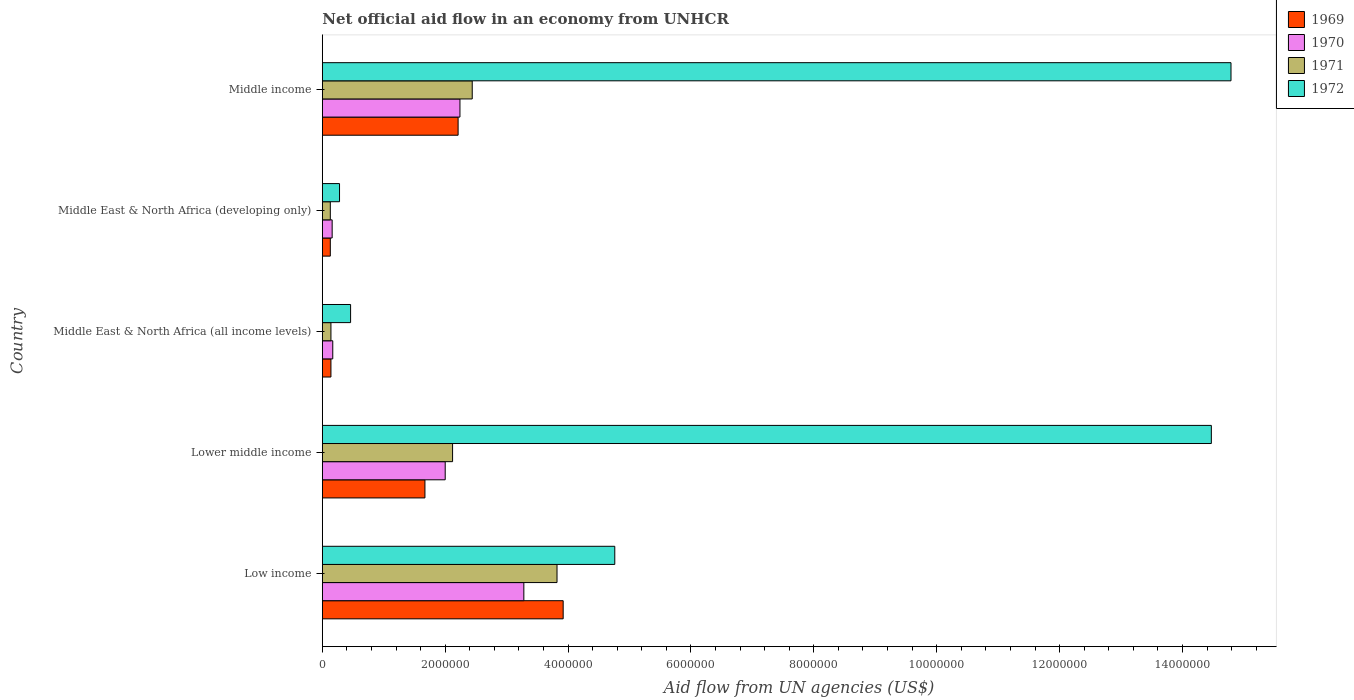How many different coloured bars are there?
Make the answer very short. 4. How many bars are there on the 3rd tick from the top?
Make the answer very short. 4. How many bars are there on the 1st tick from the bottom?
Your answer should be very brief. 4. What is the label of the 3rd group of bars from the top?
Provide a short and direct response. Middle East & North Africa (all income levels). What is the net official aid flow in 1969 in Middle income?
Your response must be concise. 2.21e+06. Across all countries, what is the maximum net official aid flow in 1972?
Provide a succinct answer. 1.48e+07. Across all countries, what is the minimum net official aid flow in 1970?
Offer a terse response. 1.60e+05. In which country was the net official aid flow in 1971 minimum?
Provide a short and direct response. Middle East & North Africa (developing only). What is the total net official aid flow in 1970 in the graph?
Your answer should be compact. 7.85e+06. What is the difference between the net official aid flow in 1971 in Middle income and the net official aid flow in 1972 in Low income?
Ensure brevity in your answer.  -2.32e+06. What is the average net official aid flow in 1971 per country?
Provide a short and direct response. 1.73e+06. What is the difference between the net official aid flow in 1972 and net official aid flow in 1970 in Middle income?
Give a very brief answer. 1.26e+07. What is the difference between the highest and the second highest net official aid flow in 1970?
Your response must be concise. 1.04e+06. What is the difference between the highest and the lowest net official aid flow in 1969?
Your response must be concise. 3.79e+06. Is it the case that in every country, the sum of the net official aid flow in 1971 and net official aid flow in 1969 is greater than the sum of net official aid flow in 1972 and net official aid flow in 1970?
Provide a succinct answer. No. What does the 4th bar from the top in Lower middle income represents?
Keep it short and to the point. 1969. What does the 1st bar from the bottom in Low income represents?
Offer a very short reply. 1969. How many countries are there in the graph?
Your answer should be compact. 5. How many legend labels are there?
Give a very brief answer. 4. How are the legend labels stacked?
Make the answer very short. Vertical. What is the title of the graph?
Ensure brevity in your answer.  Net official aid flow in an economy from UNHCR. What is the label or title of the X-axis?
Keep it short and to the point. Aid flow from UN agencies (US$). What is the label or title of the Y-axis?
Your answer should be compact. Country. What is the Aid flow from UN agencies (US$) in 1969 in Low income?
Keep it short and to the point. 3.92e+06. What is the Aid flow from UN agencies (US$) in 1970 in Low income?
Your answer should be compact. 3.28e+06. What is the Aid flow from UN agencies (US$) in 1971 in Low income?
Your answer should be compact. 3.82e+06. What is the Aid flow from UN agencies (US$) in 1972 in Low income?
Ensure brevity in your answer.  4.76e+06. What is the Aid flow from UN agencies (US$) of 1969 in Lower middle income?
Your response must be concise. 1.67e+06. What is the Aid flow from UN agencies (US$) in 1970 in Lower middle income?
Your answer should be very brief. 2.00e+06. What is the Aid flow from UN agencies (US$) of 1971 in Lower middle income?
Keep it short and to the point. 2.12e+06. What is the Aid flow from UN agencies (US$) of 1972 in Lower middle income?
Ensure brevity in your answer.  1.45e+07. What is the Aid flow from UN agencies (US$) in 1969 in Middle East & North Africa (all income levels)?
Provide a short and direct response. 1.40e+05. What is the Aid flow from UN agencies (US$) of 1970 in Middle East & North Africa (all income levels)?
Provide a short and direct response. 1.70e+05. What is the Aid flow from UN agencies (US$) of 1971 in Middle East & North Africa (all income levels)?
Your response must be concise. 1.40e+05. What is the Aid flow from UN agencies (US$) in 1972 in Middle East & North Africa (all income levels)?
Keep it short and to the point. 4.60e+05. What is the Aid flow from UN agencies (US$) in 1970 in Middle East & North Africa (developing only)?
Your response must be concise. 1.60e+05. What is the Aid flow from UN agencies (US$) in 1972 in Middle East & North Africa (developing only)?
Offer a terse response. 2.80e+05. What is the Aid flow from UN agencies (US$) in 1969 in Middle income?
Offer a very short reply. 2.21e+06. What is the Aid flow from UN agencies (US$) of 1970 in Middle income?
Give a very brief answer. 2.24e+06. What is the Aid flow from UN agencies (US$) of 1971 in Middle income?
Ensure brevity in your answer.  2.44e+06. What is the Aid flow from UN agencies (US$) of 1972 in Middle income?
Provide a succinct answer. 1.48e+07. Across all countries, what is the maximum Aid flow from UN agencies (US$) in 1969?
Make the answer very short. 3.92e+06. Across all countries, what is the maximum Aid flow from UN agencies (US$) of 1970?
Keep it short and to the point. 3.28e+06. Across all countries, what is the maximum Aid flow from UN agencies (US$) in 1971?
Keep it short and to the point. 3.82e+06. Across all countries, what is the maximum Aid flow from UN agencies (US$) in 1972?
Offer a very short reply. 1.48e+07. Across all countries, what is the minimum Aid flow from UN agencies (US$) of 1969?
Your response must be concise. 1.30e+05. Across all countries, what is the minimum Aid flow from UN agencies (US$) of 1971?
Provide a short and direct response. 1.30e+05. Across all countries, what is the minimum Aid flow from UN agencies (US$) in 1972?
Offer a very short reply. 2.80e+05. What is the total Aid flow from UN agencies (US$) of 1969 in the graph?
Make the answer very short. 8.07e+06. What is the total Aid flow from UN agencies (US$) in 1970 in the graph?
Offer a terse response. 7.85e+06. What is the total Aid flow from UN agencies (US$) of 1971 in the graph?
Ensure brevity in your answer.  8.65e+06. What is the total Aid flow from UN agencies (US$) of 1972 in the graph?
Your answer should be compact. 3.48e+07. What is the difference between the Aid flow from UN agencies (US$) of 1969 in Low income and that in Lower middle income?
Give a very brief answer. 2.25e+06. What is the difference between the Aid flow from UN agencies (US$) in 1970 in Low income and that in Lower middle income?
Keep it short and to the point. 1.28e+06. What is the difference between the Aid flow from UN agencies (US$) of 1971 in Low income and that in Lower middle income?
Ensure brevity in your answer.  1.70e+06. What is the difference between the Aid flow from UN agencies (US$) of 1972 in Low income and that in Lower middle income?
Provide a short and direct response. -9.71e+06. What is the difference between the Aid flow from UN agencies (US$) of 1969 in Low income and that in Middle East & North Africa (all income levels)?
Your response must be concise. 3.78e+06. What is the difference between the Aid flow from UN agencies (US$) of 1970 in Low income and that in Middle East & North Africa (all income levels)?
Your answer should be compact. 3.11e+06. What is the difference between the Aid flow from UN agencies (US$) of 1971 in Low income and that in Middle East & North Africa (all income levels)?
Provide a succinct answer. 3.68e+06. What is the difference between the Aid flow from UN agencies (US$) of 1972 in Low income and that in Middle East & North Africa (all income levels)?
Your answer should be very brief. 4.30e+06. What is the difference between the Aid flow from UN agencies (US$) of 1969 in Low income and that in Middle East & North Africa (developing only)?
Ensure brevity in your answer.  3.79e+06. What is the difference between the Aid flow from UN agencies (US$) in 1970 in Low income and that in Middle East & North Africa (developing only)?
Offer a terse response. 3.12e+06. What is the difference between the Aid flow from UN agencies (US$) in 1971 in Low income and that in Middle East & North Africa (developing only)?
Your response must be concise. 3.69e+06. What is the difference between the Aid flow from UN agencies (US$) in 1972 in Low income and that in Middle East & North Africa (developing only)?
Keep it short and to the point. 4.48e+06. What is the difference between the Aid flow from UN agencies (US$) in 1969 in Low income and that in Middle income?
Provide a short and direct response. 1.71e+06. What is the difference between the Aid flow from UN agencies (US$) of 1970 in Low income and that in Middle income?
Your answer should be compact. 1.04e+06. What is the difference between the Aid flow from UN agencies (US$) of 1971 in Low income and that in Middle income?
Ensure brevity in your answer.  1.38e+06. What is the difference between the Aid flow from UN agencies (US$) in 1972 in Low income and that in Middle income?
Your answer should be very brief. -1.00e+07. What is the difference between the Aid flow from UN agencies (US$) in 1969 in Lower middle income and that in Middle East & North Africa (all income levels)?
Provide a succinct answer. 1.53e+06. What is the difference between the Aid flow from UN agencies (US$) of 1970 in Lower middle income and that in Middle East & North Africa (all income levels)?
Your answer should be very brief. 1.83e+06. What is the difference between the Aid flow from UN agencies (US$) in 1971 in Lower middle income and that in Middle East & North Africa (all income levels)?
Offer a terse response. 1.98e+06. What is the difference between the Aid flow from UN agencies (US$) in 1972 in Lower middle income and that in Middle East & North Africa (all income levels)?
Your answer should be compact. 1.40e+07. What is the difference between the Aid flow from UN agencies (US$) in 1969 in Lower middle income and that in Middle East & North Africa (developing only)?
Offer a very short reply. 1.54e+06. What is the difference between the Aid flow from UN agencies (US$) in 1970 in Lower middle income and that in Middle East & North Africa (developing only)?
Make the answer very short. 1.84e+06. What is the difference between the Aid flow from UN agencies (US$) of 1971 in Lower middle income and that in Middle East & North Africa (developing only)?
Keep it short and to the point. 1.99e+06. What is the difference between the Aid flow from UN agencies (US$) in 1972 in Lower middle income and that in Middle East & North Africa (developing only)?
Offer a very short reply. 1.42e+07. What is the difference between the Aid flow from UN agencies (US$) in 1969 in Lower middle income and that in Middle income?
Offer a terse response. -5.40e+05. What is the difference between the Aid flow from UN agencies (US$) of 1970 in Lower middle income and that in Middle income?
Offer a very short reply. -2.40e+05. What is the difference between the Aid flow from UN agencies (US$) in 1971 in Lower middle income and that in Middle income?
Give a very brief answer. -3.20e+05. What is the difference between the Aid flow from UN agencies (US$) in 1972 in Lower middle income and that in Middle income?
Offer a terse response. -3.20e+05. What is the difference between the Aid flow from UN agencies (US$) in 1972 in Middle East & North Africa (all income levels) and that in Middle East & North Africa (developing only)?
Your response must be concise. 1.80e+05. What is the difference between the Aid flow from UN agencies (US$) of 1969 in Middle East & North Africa (all income levels) and that in Middle income?
Offer a terse response. -2.07e+06. What is the difference between the Aid flow from UN agencies (US$) of 1970 in Middle East & North Africa (all income levels) and that in Middle income?
Provide a succinct answer. -2.07e+06. What is the difference between the Aid flow from UN agencies (US$) of 1971 in Middle East & North Africa (all income levels) and that in Middle income?
Provide a short and direct response. -2.30e+06. What is the difference between the Aid flow from UN agencies (US$) in 1972 in Middle East & North Africa (all income levels) and that in Middle income?
Provide a short and direct response. -1.43e+07. What is the difference between the Aid flow from UN agencies (US$) in 1969 in Middle East & North Africa (developing only) and that in Middle income?
Ensure brevity in your answer.  -2.08e+06. What is the difference between the Aid flow from UN agencies (US$) of 1970 in Middle East & North Africa (developing only) and that in Middle income?
Your response must be concise. -2.08e+06. What is the difference between the Aid flow from UN agencies (US$) of 1971 in Middle East & North Africa (developing only) and that in Middle income?
Offer a terse response. -2.31e+06. What is the difference between the Aid flow from UN agencies (US$) of 1972 in Middle East & North Africa (developing only) and that in Middle income?
Your response must be concise. -1.45e+07. What is the difference between the Aid flow from UN agencies (US$) of 1969 in Low income and the Aid flow from UN agencies (US$) of 1970 in Lower middle income?
Your answer should be very brief. 1.92e+06. What is the difference between the Aid flow from UN agencies (US$) in 1969 in Low income and the Aid flow from UN agencies (US$) in 1971 in Lower middle income?
Offer a terse response. 1.80e+06. What is the difference between the Aid flow from UN agencies (US$) of 1969 in Low income and the Aid flow from UN agencies (US$) of 1972 in Lower middle income?
Your answer should be compact. -1.06e+07. What is the difference between the Aid flow from UN agencies (US$) of 1970 in Low income and the Aid flow from UN agencies (US$) of 1971 in Lower middle income?
Ensure brevity in your answer.  1.16e+06. What is the difference between the Aid flow from UN agencies (US$) of 1970 in Low income and the Aid flow from UN agencies (US$) of 1972 in Lower middle income?
Your response must be concise. -1.12e+07. What is the difference between the Aid flow from UN agencies (US$) of 1971 in Low income and the Aid flow from UN agencies (US$) of 1972 in Lower middle income?
Make the answer very short. -1.06e+07. What is the difference between the Aid flow from UN agencies (US$) of 1969 in Low income and the Aid flow from UN agencies (US$) of 1970 in Middle East & North Africa (all income levels)?
Offer a terse response. 3.75e+06. What is the difference between the Aid flow from UN agencies (US$) in 1969 in Low income and the Aid flow from UN agencies (US$) in 1971 in Middle East & North Africa (all income levels)?
Keep it short and to the point. 3.78e+06. What is the difference between the Aid flow from UN agencies (US$) of 1969 in Low income and the Aid flow from UN agencies (US$) of 1972 in Middle East & North Africa (all income levels)?
Provide a short and direct response. 3.46e+06. What is the difference between the Aid flow from UN agencies (US$) in 1970 in Low income and the Aid flow from UN agencies (US$) in 1971 in Middle East & North Africa (all income levels)?
Make the answer very short. 3.14e+06. What is the difference between the Aid flow from UN agencies (US$) in 1970 in Low income and the Aid flow from UN agencies (US$) in 1972 in Middle East & North Africa (all income levels)?
Offer a terse response. 2.82e+06. What is the difference between the Aid flow from UN agencies (US$) of 1971 in Low income and the Aid flow from UN agencies (US$) of 1972 in Middle East & North Africa (all income levels)?
Your answer should be very brief. 3.36e+06. What is the difference between the Aid flow from UN agencies (US$) of 1969 in Low income and the Aid flow from UN agencies (US$) of 1970 in Middle East & North Africa (developing only)?
Make the answer very short. 3.76e+06. What is the difference between the Aid flow from UN agencies (US$) in 1969 in Low income and the Aid flow from UN agencies (US$) in 1971 in Middle East & North Africa (developing only)?
Offer a terse response. 3.79e+06. What is the difference between the Aid flow from UN agencies (US$) in 1969 in Low income and the Aid flow from UN agencies (US$) in 1972 in Middle East & North Africa (developing only)?
Give a very brief answer. 3.64e+06. What is the difference between the Aid flow from UN agencies (US$) in 1970 in Low income and the Aid flow from UN agencies (US$) in 1971 in Middle East & North Africa (developing only)?
Your answer should be very brief. 3.15e+06. What is the difference between the Aid flow from UN agencies (US$) in 1970 in Low income and the Aid flow from UN agencies (US$) in 1972 in Middle East & North Africa (developing only)?
Ensure brevity in your answer.  3.00e+06. What is the difference between the Aid flow from UN agencies (US$) of 1971 in Low income and the Aid flow from UN agencies (US$) of 1972 in Middle East & North Africa (developing only)?
Make the answer very short. 3.54e+06. What is the difference between the Aid flow from UN agencies (US$) of 1969 in Low income and the Aid flow from UN agencies (US$) of 1970 in Middle income?
Provide a short and direct response. 1.68e+06. What is the difference between the Aid flow from UN agencies (US$) in 1969 in Low income and the Aid flow from UN agencies (US$) in 1971 in Middle income?
Make the answer very short. 1.48e+06. What is the difference between the Aid flow from UN agencies (US$) of 1969 in Low income and the Aid flow from UN agencies (US$) of 1972 in Middle income?
Give a very brief answer. -1.09e+07. What is the difference between the Aid flow from UN agencies (US$) in 1970 in Low income and the Aid flow from UN agencies (US$) in 1971 in Middle income?
Your answer should be very brief. 8.40e+05. What is the difference between the Aid flow from UN agencies (US$) in 1970 in Low income and the Aid flow from UN agencies (US$) in 1972 in Middle income?
Your response must be concise. -1.15e+07. What is the difference between the Aid flow from UN agencies (US$) in 1971 in Low income and the Aid flow from UN agencies (US$) in 1972 in Middle income?
Your answer should be compact. -1.10e+07. What is the difference between the Aid flow from UN agencies (US$) of 1969 in Lower middle income and the Aid flow from UN agencies (US$) of 1970 in Middle East & North Africa (all income levels)?
Your answer should be compact. 1.50e+06. What is the difference between the Aid flow from UN agencies (US$) in 1969 in Lower middle income and the Aid flow from UN agencies (US$) in 1971 in Middle East & North Africa (all income levels)?
Your response must be concise. 1.53e+06. What is the difference between the Aid flow from UN agencies (US$) of 1969 in Lower middle income and the Aid flow from UN agencies (US$) of 1972 in Middle East & North Africa (all income levels)?
Provide a succinct answer. 1.21e+06. What is the difference between the Aid flow from UN agencies (US$) in 1970 in Lower middle income and the Aid flow from UN agencies (US$) in 1971 in Middle East & North Africa (all income levels)?
Provide a succinct answer. 1.86e+06. What is the difference between the Aid flow from UN agencies (US$) of 1970 in Lower middle income and the Aid flow from UN agencies (US$) of 1972 in Middle East & North Africa (all income levels)?
Provide a succinct answer. 1.54e+06. What is the difference between the Aid flow from UN agencies (US$) in 1971 in Lower middle income and the Aid flow from UN agencies (US$) in 1972 in Middle East & North Africa (all income levels)?
Offer a very short reply. 1.66e+06. What is the difference between the Aid flow from UN agencies (US$) in 1969 in Lower middle income and the Aid flow from UN agencies (US$) in 1970 in Middle East & North Africa (developing only)?
Ensure brevity in your answer.  1.51e+06. What is the difference between the Aid flow from UN agencies (US$) of 1969 in Lower middle income and the Aid flow from UN agencies (US$) of 1971 in Middle East & North Africa (developing only)?
Your answer should be compact. 1.54e+06. What is the difference between the Aid flow from UN agencies (US$) in 1969 in Lower middle income and the Aid flow from UN agencies (US$) in 1972 in Middle East & North Africa (developing only)?
Offer a terse response. 1.39e+06. What is the difference between the Aid flow from UN agencies (US$) of 1970 in Lower middle income and the Aid flow from UN agencies (US$) of 1971 in Middle East & North Africa (developing only)?
Your response must be concise. 1.87e+06. What is the difference between the Aid flow from UN agencies (US$) in 1970 in Lower middle income and the Aid flow from UN agencies (US$) in 1972 in Middle East & North Africa (developing only)?
Offer a terse response. 1.72e+06. What is the difference between the Aid flow from UN agencies (US$) of 1971 in Lower middle income and the Aid flow from UN agencies (US$) of 1972 in Middle East & North Africa (developing only)?
Make the answer very short. 1.84e+06. What is the difference between the Aid flow from UN agencies (US$) of 1969 in Lower middle income and the Aid flow from UN agencies (US$) of 1970 in Middle income?
Your answer should be compact. -5.70e+05. What is the difference between the Aid flow from UN agencies (US$) in 1969 in Lower middle income and the Aid flow from UN agencies (US$) in 1971 in Middle income?
Ensure brevity in your answer.  -7.70e+05. What is the difference between the Aid flow from UN agencies (US$) of 1969 in Lower middle income and the Aid flow from UN agencies (US$) of 1972 in Middle income?
Offer a very short reply. -1.31e+07. What is the difference between the Aid flow from UN agencies (US$) in 1970 in Lower middle income and the Aid flow from UN agencies (US$) in 1971 in Middle income?
Make the answer very short. -4.40e+05. What is the difference between the Aid flow from UN agencies (US$) in 1970 in Lower middle income and the Aid flow from UN agencies (US$) in 1972 in Middle income?
Offer a very short reply. -1.28e+07. What is the difference between the Aid flow from UN agencies (US$) in 1971 in Lower middle income and the Aid flow from UN agencies (US$) in 1972 in Middle income?
Your answer should be very brief. -1.27e+07. What is the difference between the Aid flow from UN agencies (US$) in 1969 in Middle East & North Africa (all income levels) and the Aid flow from UN agencies (US$) in 1972 in Middle East & North Africa (developing only)?
Make the answer very short. -1.40e+05. What is the difference between the Aid flow from UN agencies (US$) of 1969 in Middle East & North Africa (all income levels) and the Aid flow from UN agencies (US$) of 1970 in Middle income?
Your response must be concise. -2.10e+06. What is the difference between the Aid flow from UN agencies (US$) of 1969 in Middle East & North Africa (all income levels) and the Aid flow from UN agencies (US$) of 1971 in Middle income?
Ensure brevity in your answer.  -2.30e+06. What is the difference between the Aid flow from UN agencies (US$) in 1969 in Middle East & North Africa (all income levels) and the Aid flow from UN agencies (US$) in 1972 in Middle income?
Provide a succinct answer. -1.46e+07. What is the difference between the Aid flow from UN agencies (US$) of 1970 in Middle East & North Africa (all income levels) and the Aid flow from UN agencies (US$) of 1971 in Middle income?
Offer a terse response. -2.27e+06. What is the difference between the Aid flow from UN agencies (US$) in 1970 in Middle East & North Africa (all income levels) and the Aid flow from UN agencies (US$) in 1972 in Middle income?
Your answer should be very brief. -1.46e+07. What is the difference between the Aid flow from UN agencies (US$) of 1971 in Middle East & North Africa (all income levels) and the Aid flow from UN agencies (US$) of 1972 in Middle income?
Keep it short and to the point. -1.46e+07. What is the difference between the Aid flow from UN agencies (US$) of 1969 in Middle East & North Africa (developing only) and the Aid flow from UN agencies (US$) of 1970 in Middle income?
Give a very brief answer. -2.11e+06. What is the difference between the Aid flow from UN agencies (US$) of 1969 in Middle East & North Africa (developing only) and the Aid flow from UN agencies (US$) of 1971 in Middle income?
Provide a succinct answer. -2.31e+06. What is the difference between the Aid flow from UN agencies (US$) in 1969 in Middle East & North Africa (developing only) and the Aid flow from UN agencies (US$) in 1972 in Middle income?
Your answer should be very brief. -1.47e+07. What is the difference between the Aid flow from UN agencies (US$) in 1970 in Middle East & North Africa (developing only) and the Aid flow from UN agencies (US$) in 1971 in Middle income?
Your answer should be compact. -2.28e+06. What is the difference between the Aid flow from UN agencies (US$) in 1970 in Middle East & North Africa (developing only) and the Aid flow from UN agencies (US$) in 1972 in Middle income?
Offer a terse response. -1.46e+07. What is the difference between the Aid flow from UN agencies (US$) in 1971 in Middle East & North Africa (developing only) and the Aid flow from UN agencies (US$) in 1972 in Middle income?
Give a very brief answer. -1.47e+07. What is the average Aid flow from UN agencies (US$) of 1969 per country?
Provide a succinct answer. 1.61e+06. What is the average Aid flow from UN agencies (US$) in 1970 per country?
Keep it short and to the point. 1.57e+06. What is the average Aid flow from UN agencies (US$) in 1971 per country?
Provide a succinct answer. 1.73e+06. What is the average Aid flow from UN agencies (US$) of 1972 per country?
Keep it short and to the point. 6.95e+06. What is the difference between the Aid flow from UN agencies (US$) of 1969 and Aid flow from UN agencies (US$) of 1970 in Low income?
Your response must be concise. 6.40e+05. What is the difference between the Aid flow from UN agencies (US$) of 1969 and Aid flow from UN agencies (US$) of 1972 in Low income?
Your answer should be very brief. -8.40e+05. What is the difference between the Aid flow from UN agencies (US$) in 1970 and Aid flow from UN agencies (US$) in 1971 in Low income?
Make the answer very short. -5.40e+05. What is the difference between the Aid flow from UN agencies (US$) of 1970 and Aid flow from UN agencies (US$) of 1972 in Low income?
Offer a very short reply. -1.48e+06. What is the difference between the Aid flow from UN agencies (US$) of 1971 and Aid flow from UN agencies (US$) of 1972 in Low income?
Ensure brevity in your answer.  -9.40e+05. What is the difference between the Aid flow from UN agencies (US$) in 1969 and Aid flow from UN agencies (US$) in 1970 in Lower middle income?
Keep it short and to the point. -3.30e+05. What is the difference between the Aid flow from UN agencies (US$) of 1969 and Aid flow from UN agencies (US$) of 1971 in Lower middle income?
Your answer should be very brief. -4.50e+05. What is the difference between the Aid flow from UN agencies (US$) of 1969 and Aid flow from UN agencies (US$) of 1972 in Lower middle income?
Your answer should be very brief. -1.28e+07. What is the difference between the Aid flow from UN agencies (US$) in 1970 and Aid flow from UN agencies (US$) in 1971 in Lower middle income?
Your response must be concise. -1.20e+05. What is the difference between the Aid flow from UN agencies (US$) in 1970 and Aid flow from UN agencies (US$) in 1972 in Lower middle income?
Your response must be concise. -1.25e+07. What is the difference between the Aid flow from UN agencies (US$) of 1971 and Aid flow from UN agencies (US$) of 1972 in Lower middle income?
Give a very brief answer. -1.24e+07. What is the difference between the Aid flow from UN agencies (US$) in 1969 and Aid flow from UN agencies (US$) in 1970 in Middle East & North Africa (all income levels)?
Offer a terse response. -3.00e+04. What is the difference between the Aid flow from UN agencies (US$) in 1969 and Aid flow from UN agencies (US$) in 1971 in Middle East & North Africa (all income levels)?
Give a very brief answer. 0. What is the difference between the Aid flow from UN agencies (US$) in 1969 and Aid flow from UN agencies (US$) in 1972 in Middle East & North Africa (all income levels)?
Keep it short and to the point. -3.20e+05. What is the difference between the Aid flow from UN agencies (US$) in 1970 and Aid flow from UN agencies (US$) in 1971 in Middle East & North Africa (all income levels)?
Your answer should be compact. 3.00e+04. What is the difference between the Aid flow from UN agencies (US$) of 1970 and Aid flow from UN agencies (US$) of 1972 in Middle East & North Africa (all income levels)?
Offer a terse response. -2.90e+05. What is the difference between the Aid flow from UN agencies (US$) in 1971 and Aid flow from UN agencies (US$) in 1972 in Middle East & North Africa (all income levels)?
Give a very brief answer. -3.20e+05. What is the difference between the Aid flow from UN agencies (US$) in 1969 and Aid flow from UN agencies (US$) in 1970 in Middle East & North Africa (developing only)?
Make the answer very short. -3.00e+04. What is the difference between the Aid flow from UN agencies (US$) of 1969 and Aid flow from UN agencies (US$) of 1972 in Middle income?
Offer a terse response. -1.26e+07. What is the difference between the Aid flow from UN agencies (US$) in 1970 and Aid flow from UN agencies (US$) in 1972 in Middle income?
Offer a terse response. -1.26e+07. What is the difference between the Aid flow from UN agencies (US$) of 1971 and Aid flow from UN agencies (US$) of 1972 in Middle income?
Provide a short and direct response. -1.24e+07. What is the ratio of the Aid flow from UN agencies (US$) of 1969 in Low income to that in Lower middle income?
Offer a terse response. 2.35. What is the ratio of the Aid flow from UN agencies (US$) in 1970 in Low income to that in Lower middle income?
Keep it short and to the point. 1.64. What is the ratio of the Aid flow from UN agencies (US$) of 1971 in Low income to that in Lower middle income?
Keep it short and to the point. 1.8. What is the ratio of the Aid flow from UN agencies (US$) in 1972 in Low income to that in Lower middle income?
Ensure brevity in your answer.  0.33. What is the ratio of the Aid flow from UN agencies (US$) in 1970 in Low income to that in Middle East & North Africa (all income levels)?
Provide a short and direct response. 19.29. What is the ratio of the Aid flow from UN agencies (US$) in 1971 in Low income to that in Middle East & North Africa (all income levels)?
Provide a short and direct response. 27.29. What is the ratio of the Aid flow from UN agencies (US$) of 1972 in Low income to that in Middle East & North Africa (all income levels)?
Your answer should be very brief. 10.35. What is the ratio of the Aid flow from UN agencies (US$) in 1969 in Low income to that in Middle East & North Africa (developing only)?
Ensure brevity in your answer.  30.15. What is the ratio of the Aid flow from UN agencies (US$) of 1970 in Low income to that in Middle East & North Africa (developing only)?
Make the answer very short. 20.5. What is the ratio of the Aid flow from UN agencies (US$) in 1971 in Low income to that in Middle East & North Africa (developing only)?
Provide a succinct answer. 29.38. What is the ratio of the Aid flow from UN agencies (US$) of 1972 in Low income to that in Middle East & North Africa (developing only)?
Make the answer very short. 17. What is the ratio of the Aid flow from UN agencies (US$) in 1969 in Low income to that in Middle income?
Your answer should be very brief. 1.77. What is the ratio of the Aid flow from UN agencies (US$) of 1970 in Low income to that in Middle income?
Make the answer very short. 1.46. What is the ratio of the Aid flow from UN agencies (US$) in 1971 in Low income to that in Middle income?
Provide a short and direct response. 1.57. What is the ratio of the Aid flow from UN agencies (US$) of 1972 in Low income to that in Middle income?
Provide a short and direct response. 0.32. What is the ratio of the Aid flow from UN agencies (US$) in 1969 in Lower middle income to that in Middle East & North Africa (all income levels)?
Offer a terse response. 11.93. What is the ratio of the Aid flow from UN agencies (US$) in 1970 in Lower middle income to that in Middle East & North Africa (all income levels)?
Your response must be concise. 11.76. What is the ratio of the Aid flow from UN agencies (US$) of 1971 in Lower middle income to that in Middle East & North Africa (all income levels)?
Keep it short and to the point. 15.14. What is the ratio of the Aid flow from UN agencies (US$) in 1972 in Lower middle income to that in Middle East & North Africa (all income levels)?
Provide a succinct answer. 31.46. What is the ratio of the Aid flow from UN agencies (US$) in 1969 in Lower middle income to that in Middle East & North Africa (developing only)?
Make the answer very short. 12.85. What is the ratio of the Aid flow from UN agencies (US$) of 1971 in Lower middle income to that in Middle East & North Africa (developing only)?
Give a very brief answer. 16.31. What is the ratio of the Aid flow from UN agencies (US$) in 1972 in Lower middle income to that in Middle East & North Africa (developing only)?
Your answer should be very brief. 51.68. What is the ratio of the Aid flow from UN agencies (US$) of 1969 in Lower middle income to that in Middle income?
Offer a terse response. 0.76. What is the ratio of the Aid flow from UN agencies (US$) in 1970 in Lower middle income to that in Middle income?
Your answer should be compact. 0.89. What is the ratio of the Aid flow from UN agencies (US$) of 1971 in Lower middle income to that in Middle income?
Your answer should be compact. 0.87. What is the ratio of the Aid flow from UN agencies (US$) of 1972 in Lower middle income to that in Middle income?
Make the answer very short. 0.98. What is the ratio of the Aid flow from UN agencies (US$) in 1969 in Middle East & North Africa (all income levels) to that in Middle East & North Africa (developing only)?
Offer a terse response. 1.08. What is the ratio of the Aid flow from UN agencies (US$) in 1972 in Middle East & North Africa (all income levels) to that in Middle East & North Africa (developing only)?
Give a very brief answer. 1.64. What is the ratio of the Aid flow from UN agencies (US$) in 1969 in Middle East & North Africa (all income levels) to that in Middle income?
Your answer should be very brief. 0.06. What is the ratio of the Aid flow from UN agencies (US$) in 1970 in Middle East & North Africa (all income levels) to that in Middle income?
Your response must be concise. 0.08. What is the ratio of the Aid flow from UN agencies (US$) of 1971 in Middle East & North Africa (all income levels) to that in Middle income?
Your response must be concise. 0.06. What is the ratio of the Aid flow from UN agencies (US$) of 1972 in Middle East & North Africa (all income levels) to that in Middle income?
Your answer should be very brief. 0.03. What is the ratio of the Aid flow from UN agencies (US$) in 1969 in Middle East & North Africa (developing only) to that in Middle income?
Your answer should be very brief. 0.06. What is the ratio of the Aid flow from UN agencies (US$) in 1970 in Middle East & North Africa (developing only) to that in Middle income?
Offer a terse response. 0.07. What is the ratio of the Aid flow from UN agencies (US$) in 1971 in Middle East & North Africa (developing only) to that in Middle income?
Your response must be concise. 0.05. What is the ratio of the Aid flow from UN agencies (US$) of 1972 in Middle East & North Africa (developing only) to that in Middle income?
Keep it short and to the point. 0.02. What is the difference between the highest and the second highest Aid flow from UN agencies (US$) in 1969?
Ensure brevity in your answer.  1.71e+06. What is the difference between the highest and the second highest Aid flow from UN agencies (US$) in 1970?
Provide a succinct answer. 1.04e+06. What is the difference between the highest and the second highest Aid flow from UN agencies (US$) of 1971?
Your answer should be compact. 1.38e+06. What is the difference between the highest and the second highest Aid flow from UN agencies (US$) in 1972?
Keep it short and to the point. 3.20e+05. What is the difference between the highest and the lowest Aid flow from UN agencies (US$) in 1969?
Provide a succinct answer. 3.79e+06. What is the difference between the highest and the lowest Aid flow from UN agencies (US$) in 1970?
Make the answer very short. 3.12e+06. What is the difference between the highest and the lowest Aid flow from UN agencies (US$) in 1971?
Your answer should be very brief. 3.69e+06. What is the difference between the highest and the lowest Aid flow from UN agencies (US$) of 1972?
Offer a very short reply. 1.45e+07. 